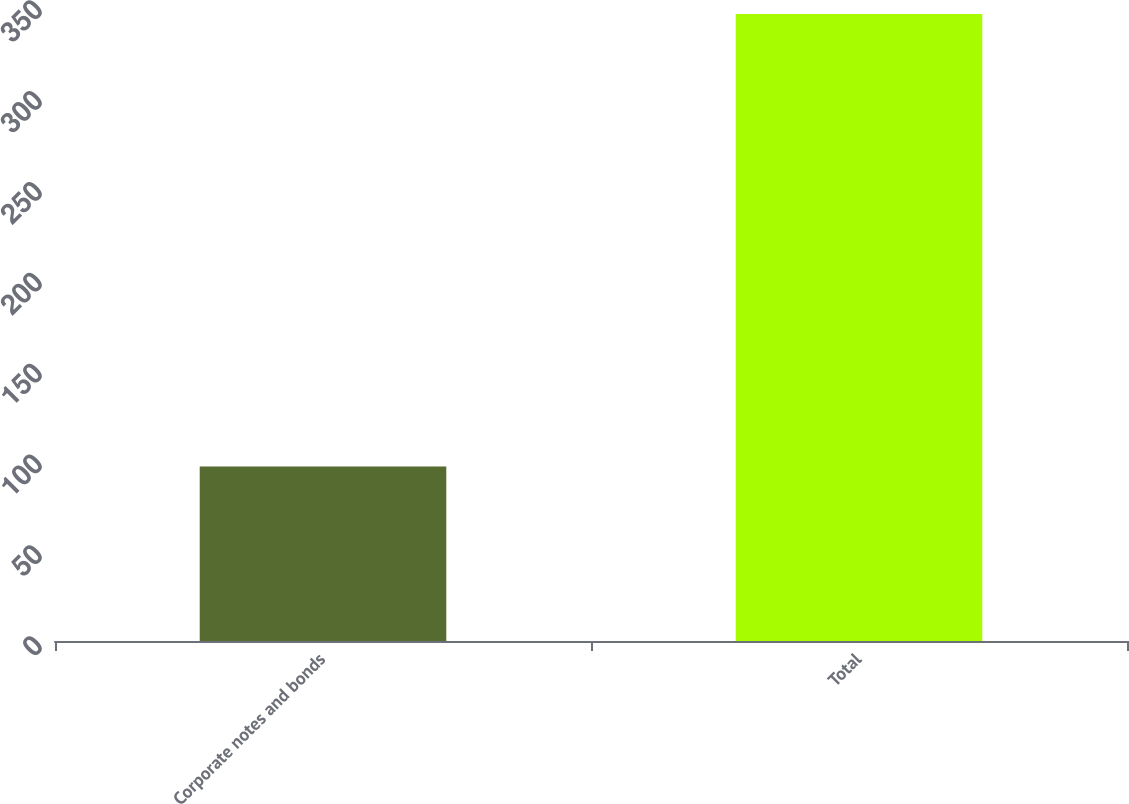<chart> <loc_0><loc_0><loc_500><loc_500><bar_chart><fcel>Corporate notes and bonds<fcel>Total<nl><fcel>96<fcel>345<nl></chart> 